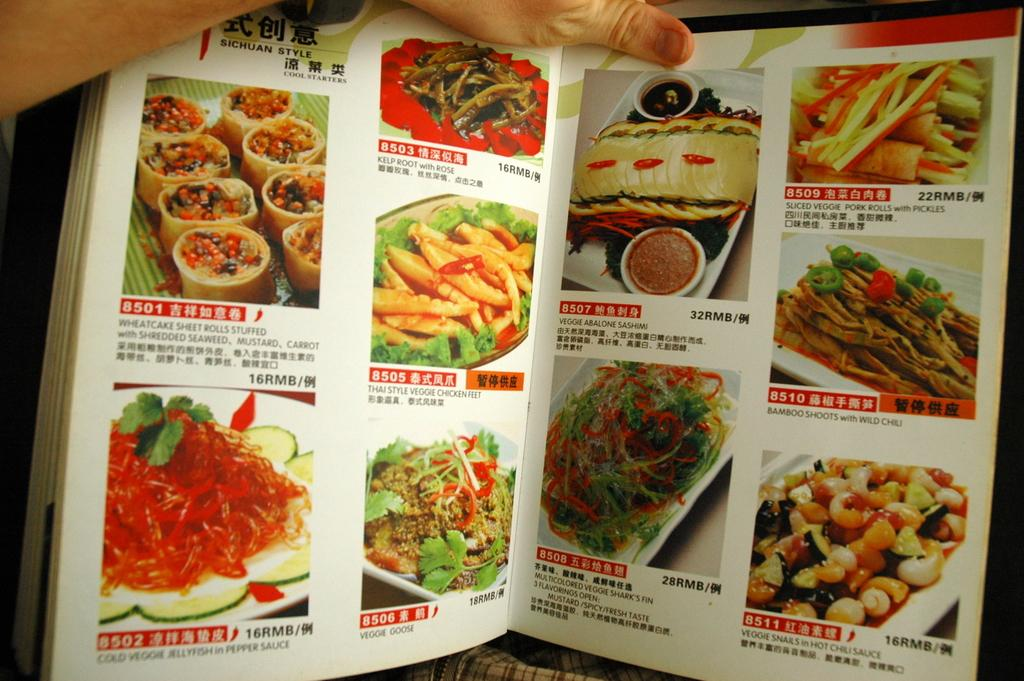What type of content is featured in the books in the image? The books contain pictures of food items. Are there any other elements in the books besides the pictures? Yes, there is text in the book. Can you describe any other details visible in the image? There is a hand of a person visible in the image. What type of alley can be seen in the background of the image? There is no alley present in the image; it features books with pictures of food items, text, and a hand. 